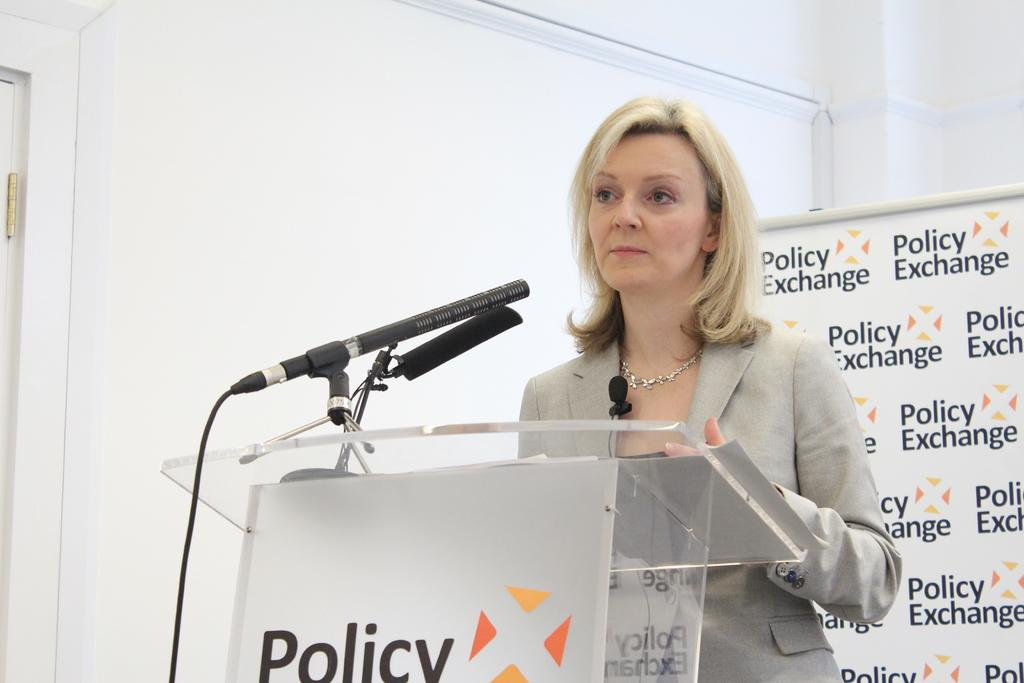Who is the main subject in the image? There is a woman in the image. What is the woman standing in front of? There is a podium in front of the woman. What can be seen on the podium? There are microphones on the podium. What is visible in the background of the image? There is a board and a wall in the background of the image. How many bikes are parked near the woman in the image? There are no bikes present in the image. What type of flock can be seen flying in the background of the image? There is no flock visible in the image; only a board and a wall are present in the background. 